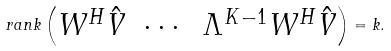<formula> <loc_0><loc_0><loc_500><loc_500>r a n k \begin{pmatrix} W ^ { H } \hat { V } & \cdots & \Lambda ^ { K - 1 } W ^ { H } \hat { V } \end{pmatrix} = k .</formula> 